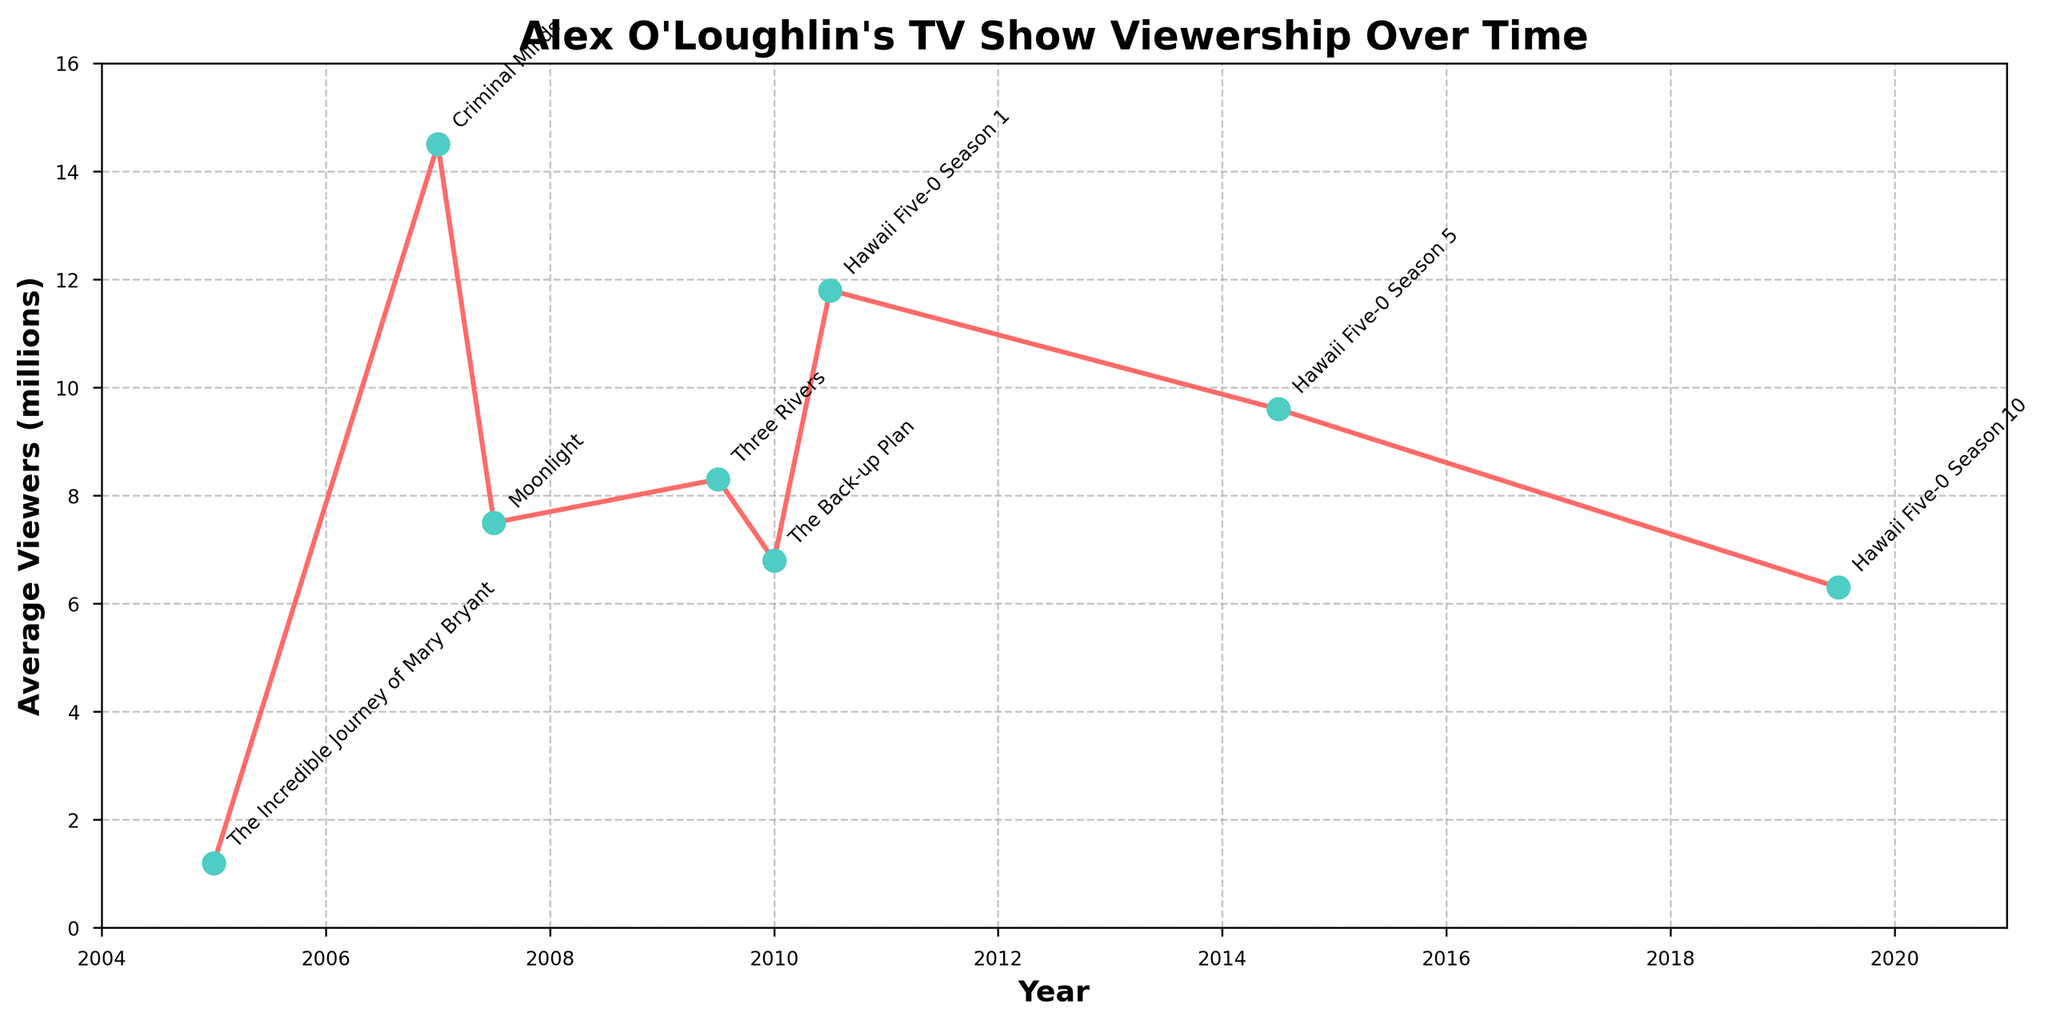Which TV show had the lowest average viewership? The TV show with the lowest average viewership can be identified by looking at the lowest point on the y-axis. This point corresponds to "The Incredible Journey of Mary Bryant" in 2005 with 1.2 million viewers.
Answer: The Incredible Journey of Mary Bryant Between "Moonlight" and "Three Rivers," which show had a higher average viewership? To determine which show had a higher viewership, compare the points for "Moonlight" and "Three Rivers" on the y-axis. "Three Rivers" had 8.3 million viewers, while "Moonlight" had 7.5 million viewers.
Answer: Three Rivers What was the difference in viewership between the first and last seasons of Hawaii Five-0? Look at the viewership numbers for Hawaii Five-0 Season 1 (11.8 million) and Hawaii Five-0 Season 10 (6.3 million). Subtract the viewership of Season 10 from Season 1: 11.8 - 6.3 = 5.5 million.
Answer: 5.5 million Did Alex O'Loughlin's TV show viewership generally increase or decrease over time? By examining the overall trend from the very first to the last plotted points, the viewership generally decreases.
Answer: Decrease How many shows had an average viewership of over 10 million? Count the number of points above the 10 million mark on the y-axis. "Criminal Minds" and Hawaii Five-0 Season 1 surpass this threshold.
Answer: 2 What is the average viewership of Alex O'Loughlin's shows from "Criminal Minds" to "Hawaii Five-0 Season 10"? Find the average of the viewership numbers from "Criminal Minds" (14.5 million) to "Hawaii Five-0 Season 10" (6.3 million). This involves summing the viewership values and dividing by the number of data points. (14.5 + 7.5 + 8.3 + 6.8 + 11.8 + 9.6 + 6.3) / 7 = 64.8 / 7 ≈ 9.26 million.
Answer: 9.26 million Which year saw the highest peak in viewership? Find the highest point on the y-axis to determine the peak year. "Criminal Minds" in 2007 had the highest peak with 14.5 million viewers.
Answer: 2007 Compare the viewership of "The Back-up Plan" to "Moonlight." Which had fewer viewers? Look at the y-axis values for "The Back-up Plan" (6.8 million) and "Moonlight" (7.5 million). "The Back-up Plan" had fewer viewers.
Answer: The Back-up Plan What is the viewership trend between the three seasons of Hawaii Five-0 plotted? Examine the viewership values of the three seasons of Hawaii Five-0: Season 1 (11.8 million), Season 5 (9.6 million), and Season 10 (6.3 million). The viewership shows a declining trend.
Answer: Declining trend What is the total viewership of all the shows combined? Sum the viewership for all listed shows: 1.2 (Mary Bryant) + 14.5 (Criminal Minds) + 7.5 (Moonlight) + 8.3 (Three Rivers) + 6.8 (Back-up Plan) + 11.8 (Hawaii Five-0 Season 1) + 9.6 (Hawaii Five-0 Season 5) + 6.3 (Hawaii Five-0 Season 10) = 66 million.
Answer: 66 million 